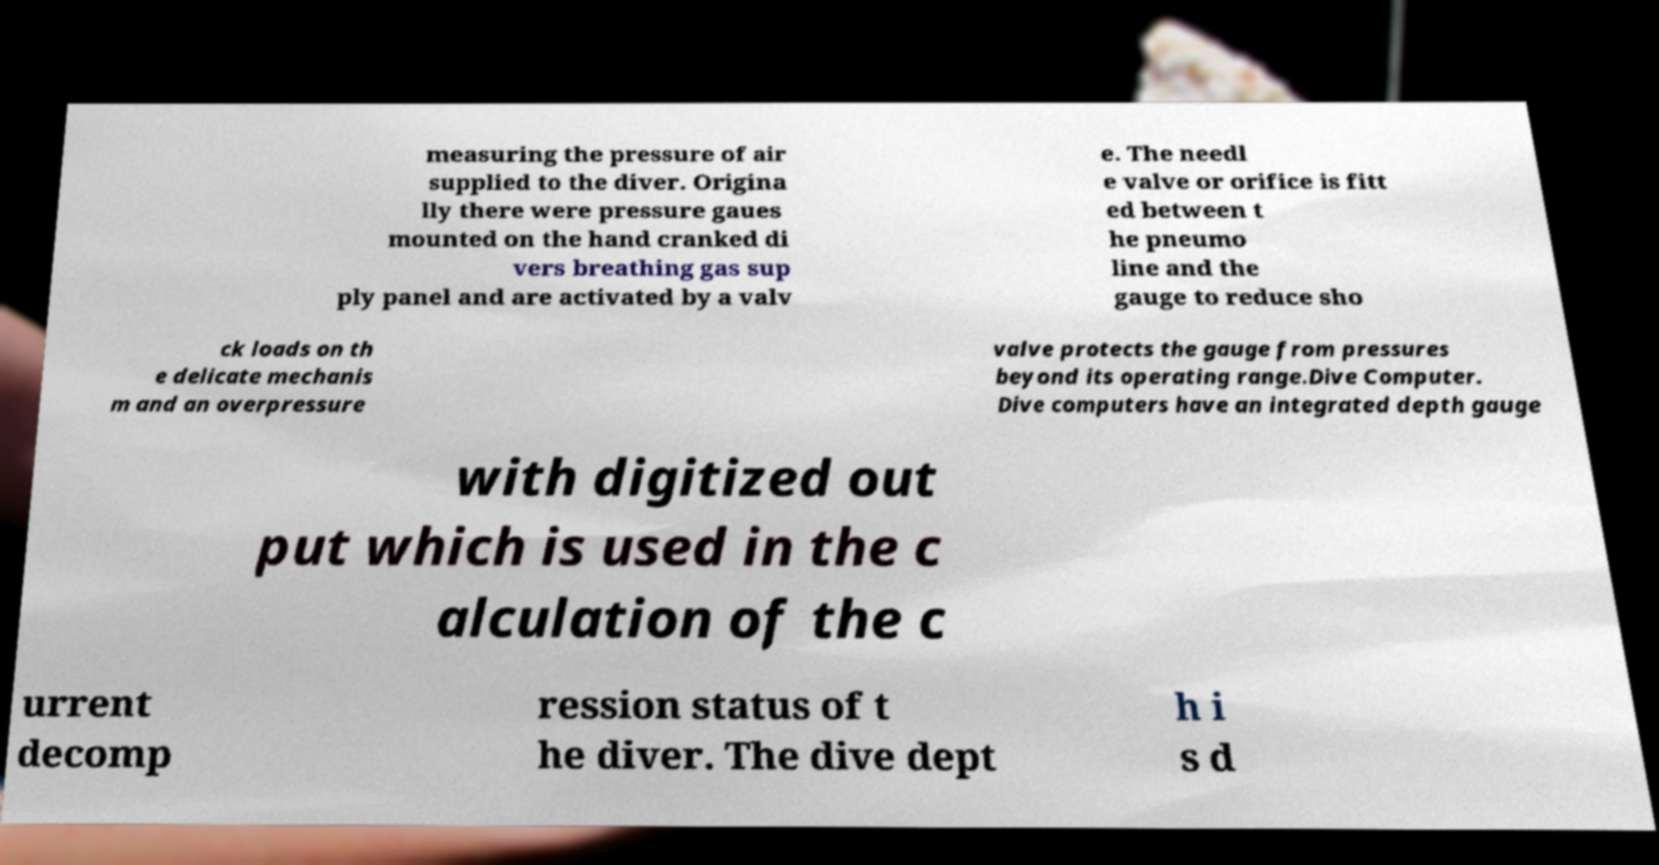Could you assist in decoding the text presented in this image and type it out clearly? measuring the pressure of air supplied to the diver. Origina lly there were pressure gaues mounted on the hand cranked di vers breathing gas sup ply panel and are activated by a valv e. The needl e valve or orifice is fitt ed between t he pneumo line and the gauge to reduce sho ck loads on th e delicate mechanis m and an overpressure valve protects the gauge from pressures beyond its operating range.Dive Computer. Dive computers have an integrated depth gauge with digitized out put which is used in the c alculation of the c urrent decomp ression status of t he diver. The dive dept h i s d 